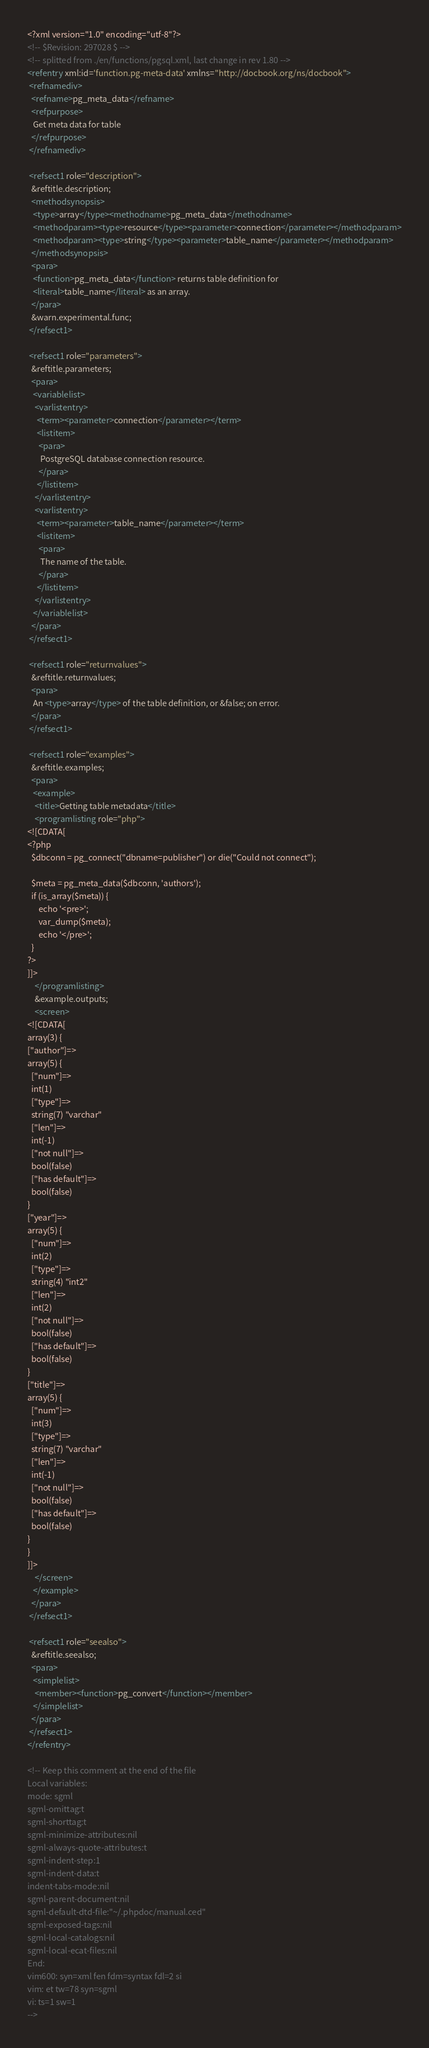<code> <loc_0><loc_0><loc_500><loc_500><_XML_><?xml version="1.0" encoding="utf-8"?>
<!-- $Revision: 297028 $ -->
<!-- splitted from ./en/functions/pgsql.xml, last change in rev 1.80 -->
<refentry xml:id='function.pg-meta-data' xmlns="http://docbook.org/ns/docbook">
 <refnamediv>
  <refname>pg_meta_data</refname>
  <refpurpose>
   Get meta data for table
  </refpurpose>
 </refnamediv>

 <refsect1 role="description">
  &reftitle.description;
  <methodsynopsis>
   <type>array</type><methodname>pg_meta_data</methodname>
   <methodparam><type>resource</type><parameter>connection</parameter></methodparam>
   <methodparam><type>string</type><parameter>table_name</parameter></methodparam>
  </methodsynopsis>
  <para>
   <function>pg_meta_data</function> returns table definition for
   <literal>table_name</literal> as an array.
  </para>
  &warn.experimental.func;
 </refsect1>

 <refsect1 role="parameters">
  &reftitle.parameters;
  <para>
   <variablelist>
    <varlistentry>
     <term><parameter>connection</parameter></term>
     <listitem>
      <para>
       PostgreSQL database connection resource.
      </para>
     </listitem>
    </varlistentry>
    <varlistentry>
     <term><parameter>table_name</parameter></term>
     <listitem>
      <para>
       The name of the table.
      </para>
     </listitem>
    </varlistentry>
   </variablelist>
  </para>
 </refsect1>

 <refsect1 role="returnvalues">
  &reftitle.returnvalues;
  <para>
   An <type>array</type> of the table definition, or &false; on error.
  </para>
 </refsect1>

 <refsect1 role="examples">
  &reftitle.examples;
  <para>
   <example>
    <title>Getting table metadata</title>
    <programlisting role="php">
<![CDATA[
<?php
  $dbconn = pg_connect("dbname=publisher") or die("Could not connect");

  $meta = pg_meta_data($dbconn, 'authors');
  if (is_array($meta)) {
      echo '<pre>';
      var_dump($meta);
      echo '</pre>';
  }
?>
]]>
    </programlisting>
    &example.outputs;
    <screen>
<![CDATA[
array(3) {
["author"]=>
array(5) {
  ["num"]=>
  int(1)
  ["type"]=>
  string(7) "varchar"
  ["len"]=>
  int(-1)
  ["not null"]=>
  bool(false)
  ["has default"]=>
  bool(false)
}
["year"]=>
array(5) {
  ["num"]=>
  int(2)
  ["type"]=>
  string(4) "int2"
  ["len"]=>
  int(2)
  ["not null"]=>
  bool(false)
  ["has default"]=>
  bool(false)
}
["title"]=>
array(5) {
  ["num"]=>
  int(3)
  ["type"]=>
  string(7) "varchar"
  ["len"]=>
  int(-1)
  ["not null"]=>
  bool(false)
  ["has default"]=>
  bool(false)
}
}
]]>
    </screen>
   </example>
  </para>
 </refsect1>

 <refsect1 role="seealso">
  &reftitle.seealso;
  <para>
   <simplelist>
    <member><function>pg_convert</function></member>
   </simplelist>
  </para>
 </refsect1>
</refentry>

<!-- Keep this comment at the end of the file
Local variables:
mode: sgml
sgml-omittag:t
sgml-shorttag:t
sgml-minimize-attributes:nil
sgml-always-quote-attributes:t
sgml-indent-step:1
sgml-indent-data:t
indent-tabs-mode:nil
sgml-parent-document:nil
sgml-default-dtd-file:"~/.phpdoc/manual.ced"
sgml-exposed-tags:nil
sgml-local-catalogs:nil
sgml-local-ecat-files:nil
End:
vim600: syn=xml fen fdm=syntax fdl=2 si
vim: et tw=78 syn=sgml
vi: ts=1 sw=1
-->
</code> 